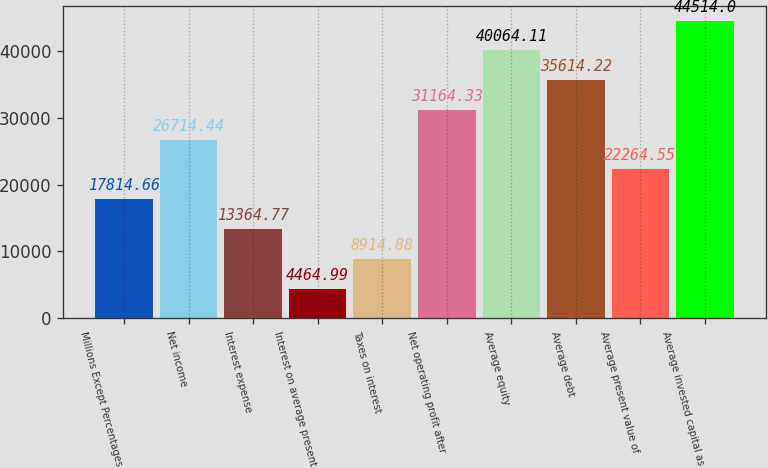Convert chart to OTSL. <chart><loc_0><loc_0><loc_500><loc_500><bar_chart><fcel>Millions Except Percentages<fcel>Net income<fcel>Interest expense<fcel>Interest on average present<fcel>Taxes on interest<fcel>Net operating profit after<fcel>Average equity<fcel>Average debt<fcel>Average present value of<fcel>Average invested capital as<nl><fcel>17814.7<fcel>26714.4<fcel>13364.8<fcel>4464.99<fcel>8914.88<fcel>31164.3<fcel>40064.1<fcel>35614.2<fcel>22264.5<fcel>44514<nl></chart> 